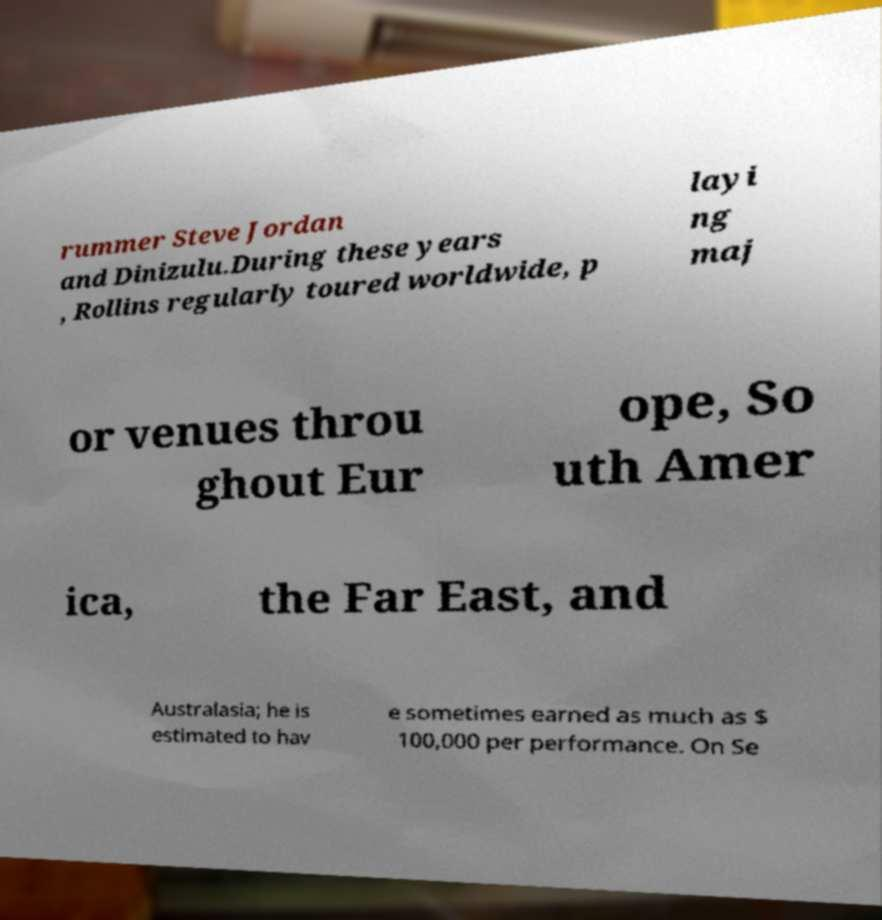Can you accurately transcribe the text from the provided image for me? rummer Steve Jordan and Dinizulu.During these years , Rollins regularly toured worldwide, p layi ng maj or venues throu ghout Eur ope, So uth Amer ica, the Far East, and Australasia; he is estimated to hav e sometimes earned as much as $ 100,000 per performance. On Se 